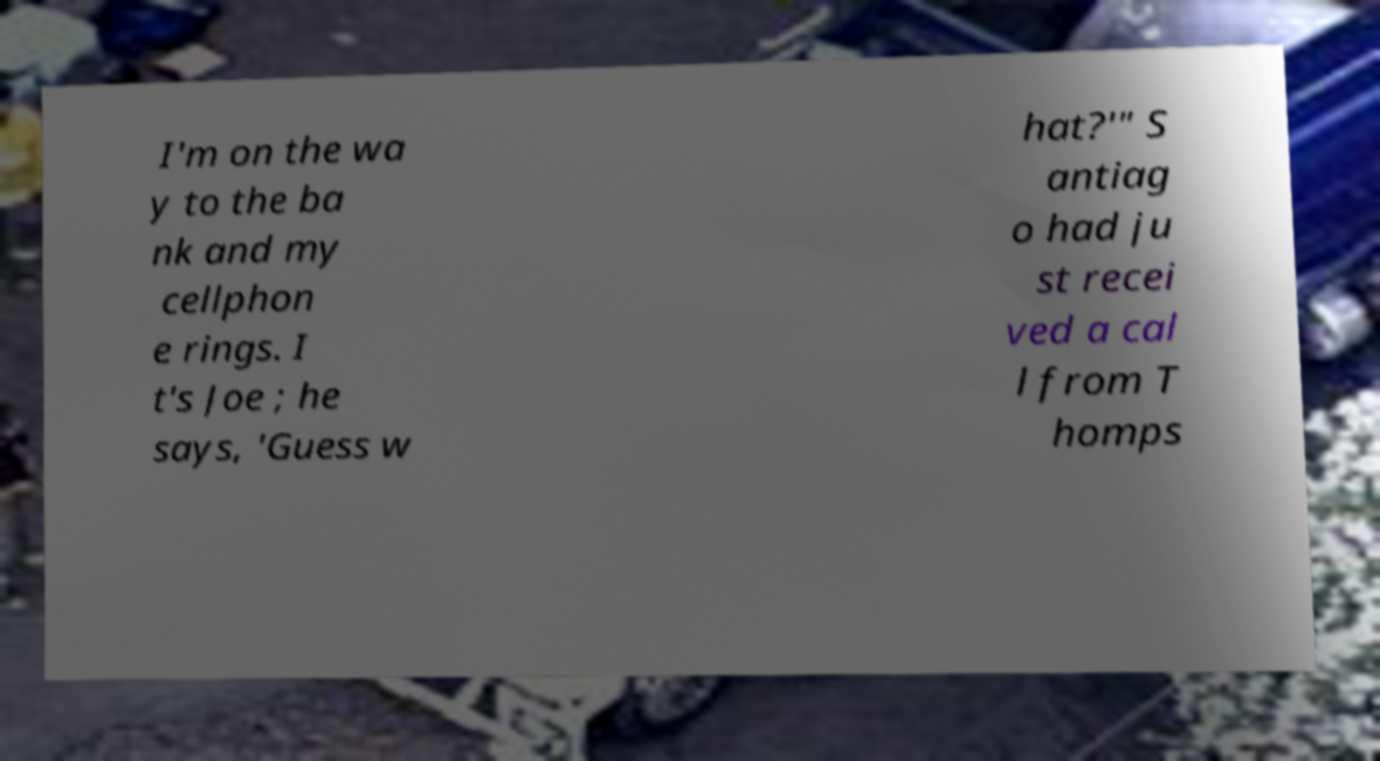There's text embedded in this image that I need extracted. Can you transcribe it verbatim? I'm on the wa y to the ba nk and my cellphon e rings. I t's Joe ; he says, 'Guess w hat?'" S antiag o had ju st recei ved a cal l from T homps 